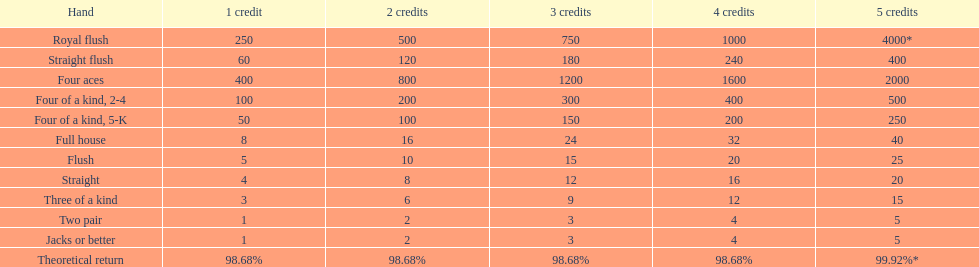Each four aces win is a multiple of what number? 400. 